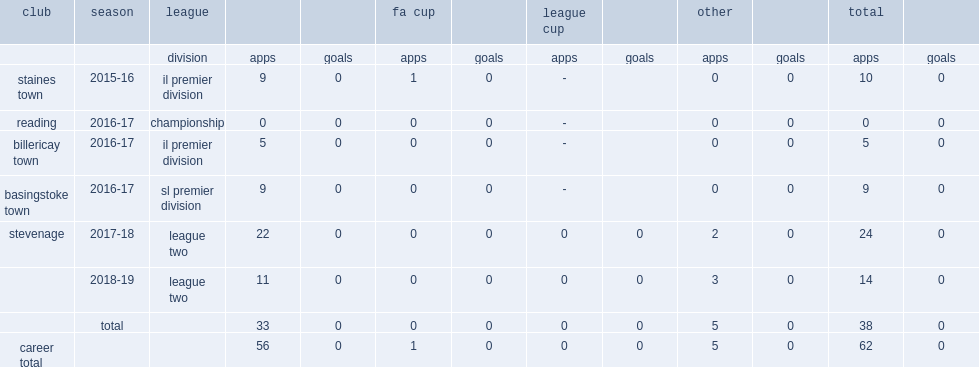Which club did terence vancooten play for in the 2016-17 season? Reading. 